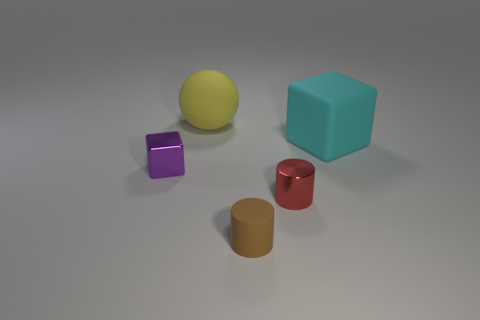Is the color of the big ball the same as the large rubber cube?
Your response must be concise. No. Is the number of purple metallic blocks that are to the right of the yellow rubber ball greater than the number of green matte blocks?
Your answer should be compact. No. How many matte objects are either tiny gray spheres or small red things?
Give a very brief answer. 0. There is a thing that is both left of the matte cylinder and on the right side of the tiny purple block; what is its size?
Your answer should be very brief. Large. There is a metal object that is left of the small red metal cylinder; is there a cube that is on the left side of it?
Your answer should be compact. No. What number of brown cylinders are in front of the big yellow sphere?
Your answer should be very brief. 1. What is the color of the other rubber thing that is the same shape as the red object?
Your answer should be compact. Brown. Is the block that is behind the tiny purple metallic object made of the same material as the thing that is behind the matte block?
Provide a succinct answer. Yes. There is a large ball; does it have the same color as the cube that is behind the small purple metallic object?
Your response must be concise. No. What is the shape of the thing that is behind the tiny purple block and left of the brown matte cylinder?
Your answer should be very brief. Sphere. 